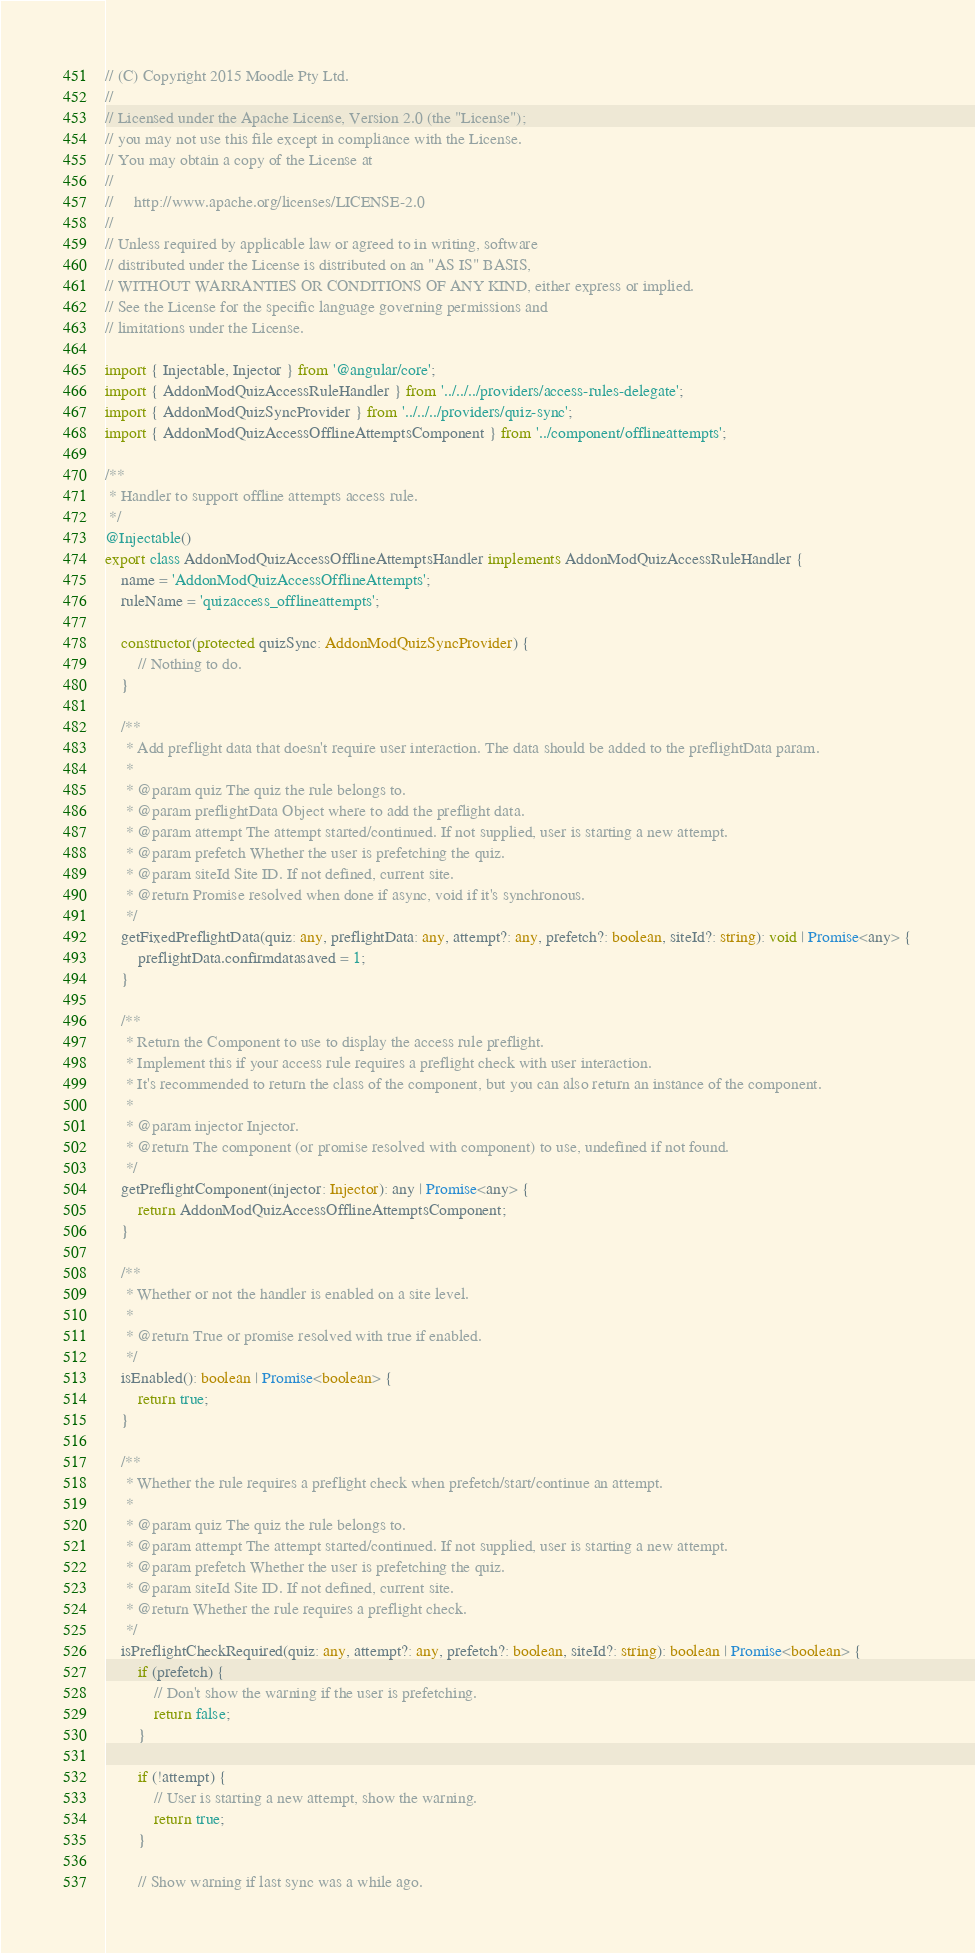<code> <loc_0><loc_0><loc_500><loc_500><_TypeScript_>
// (C) Copyright 2015 Moodle Pty Ltd.
//
// Licensed under the Apache License, Version 2.0 (the "License");
// you may not use this file except in compliance with the License.
// You may obtain a copy of the License at
//
//     http://www.apache.org/licenses/LICENSE-2.0
//
// Unless required by applicable law or agreed to in writing, software
// distributed under the License is distributed on an "AS IS" BASIS,
// WITHOUT WARRANTIES OR CONDITIONS OF ANY KIND, either express or implied.
// See the License for the specific language governing permissions and
// limitations under the License.

import { Injectable, Injector } from '@angular/core';
import { AddonModQuizAccessRuleHandler } from '../../../providers/access-rules-delegate';
import { AddonModQuizSyncProvider } from '../../../providers/quiz-sync';
import { AddonModQuizAccessOfflineAttemptsComponent } from '../component/offlineattempts';

/**
 * Handler to support offline attempts access rule.
 */
@Injectable()
export class AddonModQuizAccessOfflineAttemptsHandler implements AddonModQuizAccessRuleHandler {
    name = 'AddonModQuizAccessOfflineAttempts';
    ruleName = 'quizaccess_offlineattempts';

    constructor(protected quizSync: AddonModQuizSyncProvider) {
        // Nothing to do.
    }

    /**
     * Add preflight data that doesn't require user interaction. The data should be added to the preflightData param.
     *
     * @param quiz The quiz the rule belongs to.
     * @param preflightData Object where to add the preflight data.
     * @param attempt The attempt started/continued. If not supplied, user is starting a new attempt.
     * @param prefetch Whether the user is prefetching the quiz.
     * @param siteId Site ID. If not defined, current site.
     * @return Promise resolved when done if async, void if it's synchronous.
     */
    getFixedPreflightData(quiz: any, preflightData: any, attempt?: any, prefetch?: boolean, siteId?: string): void | Promise<any> {
        preflightData.confirmdatasaved = 1;
    }

    /**
     * Return the Component to use to display the access rule preflight.
     * Implement this if your access rule requires a preflight check with user interaction.
     * It's recommended to return the class of the component, but you can also return an instance of the component.
     *
     * @param injector Injector.
     * @return The component (or promise resolved with component) to use, undefined if not found.
     */
    getPreflightComponent(injector: Injector): any | Promise<any> {
        return AddonModQuizAccessOfflineAttemptsComponent;
    }

    /**
     * Whether or not the handler is enabled on a site level.
     *
     * @return True or promise resolved with true if enabled.
     */
    isEnabled(): boolean | Promise<boolean> {
        return true;
    }

    /**
     * Whether the rule requires a preflight check when prefetch/start/continue an attempt.
     *
     * @param quiz The quiz the rule belongs to.
     * @param attempt The attempt started/continued. If not supplied, user is starting a new attempt.
     * @param prefetch Whether the user is prefetching the quiz.
     * @param siteId Site ID. If not defined, current site.
     * @return Whether the rule requires a preflight check.
     */
    isPreflightCheckRequired(quiz: any, attempt?: any, prefetch?: boolean, siteId?: string): boolean | Promise<boolean> {
        if (prefetch) {
            // Don't show the warning if the user is prefetching.
            return false;
        }

        if (!attempt) {
            // User is starting a new attempt, show the warning.
            return true;
        }

        // Show warning if last sync was a while ago.</code> 